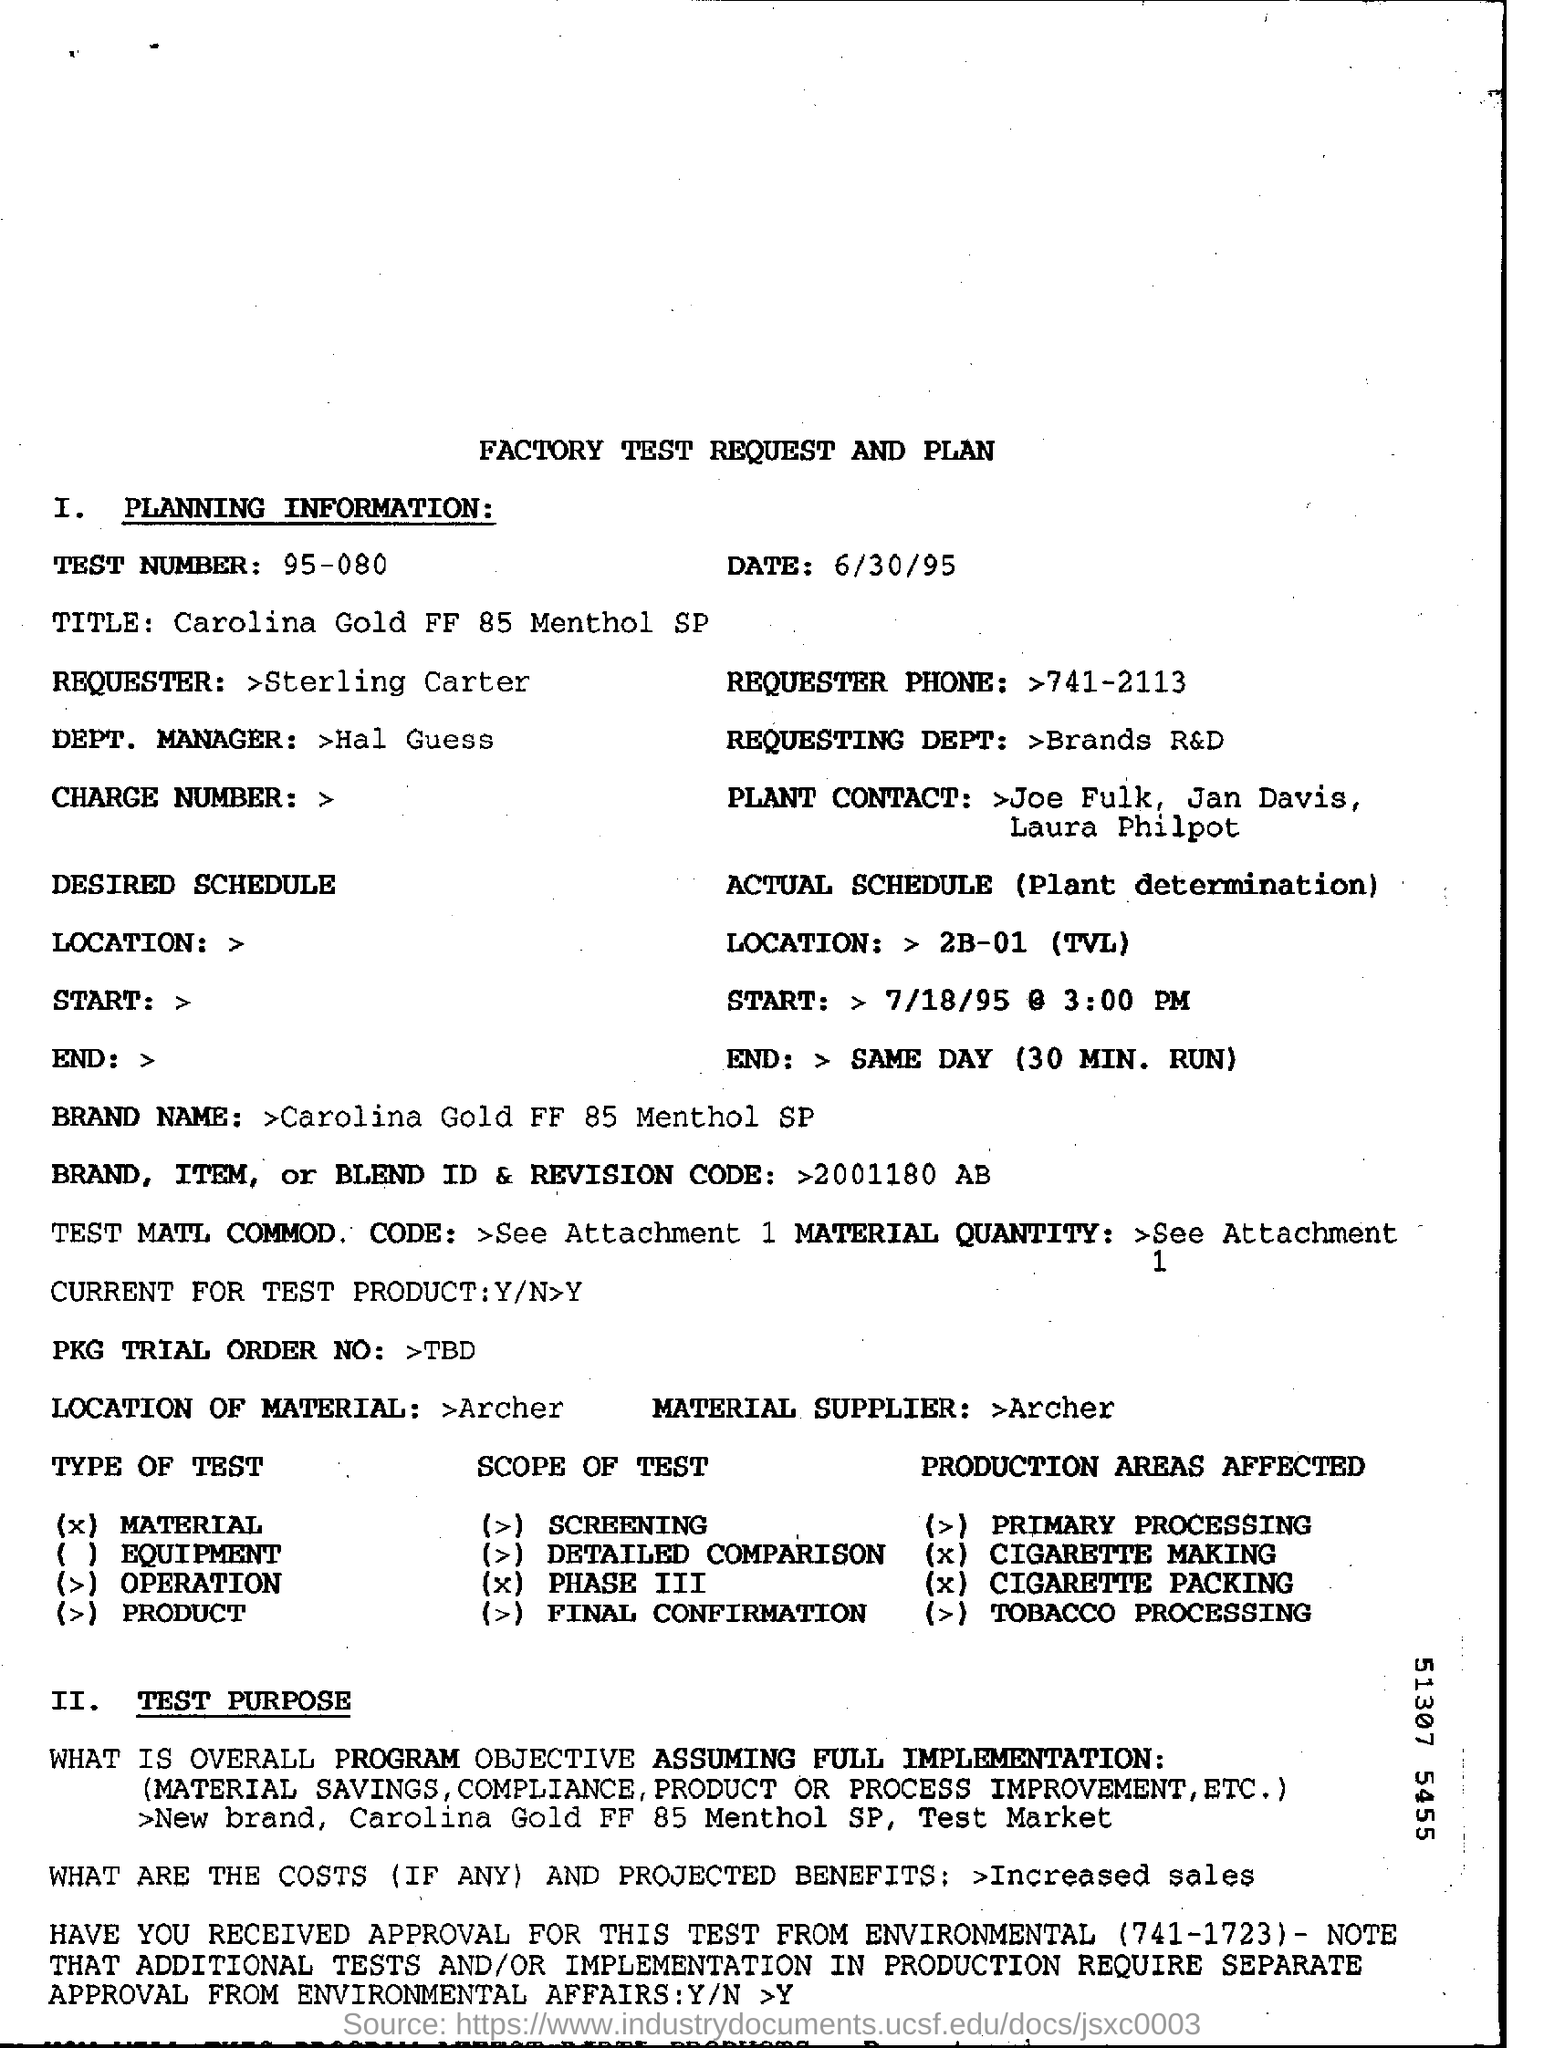What is the test umber?
Make the answer very short. 95-080. What is the test number mentioned in the document?
Your answer should be compact. 95-080. What is the brand name?
Provide a succinct answer. Carolina Gold FF 85 Menthol SP. 